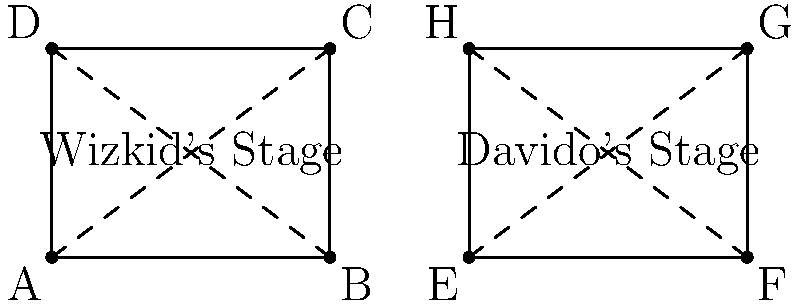In the diagram above, Wizkid's and Davido's stage layouts are represented by rectangles ABCD and EFGH respectively. If the area of Wizkid's stage is 12 square meters and the width of both stages is the same, what is the area of Davido's stage in square meters? Let's solve this step-by-step:

1) For Wizkid's stage (rectangle ABCD):
   Area = 12 sq meters
   Width = AB = 4 units (from the diagram)
   Let the length be $l$ meters
   Area = width × length
   $12 = 4 × l$
   $l = 3$ meters

2) So, the dimensions of Wizkid's stage are 4m × 3m

3) For Davido's stage (rectangle EFGH):
   Width = EF = 4 units (same as Wizkid's stage)
   Length = EH = 4 units (from the diagram)

4) Area of Davido's stage = width × length
                          = 4 × 4 = 16 sq meters

Therefore, the area of Davido's stage is 16 square meters.
Answer: 16 square meters 